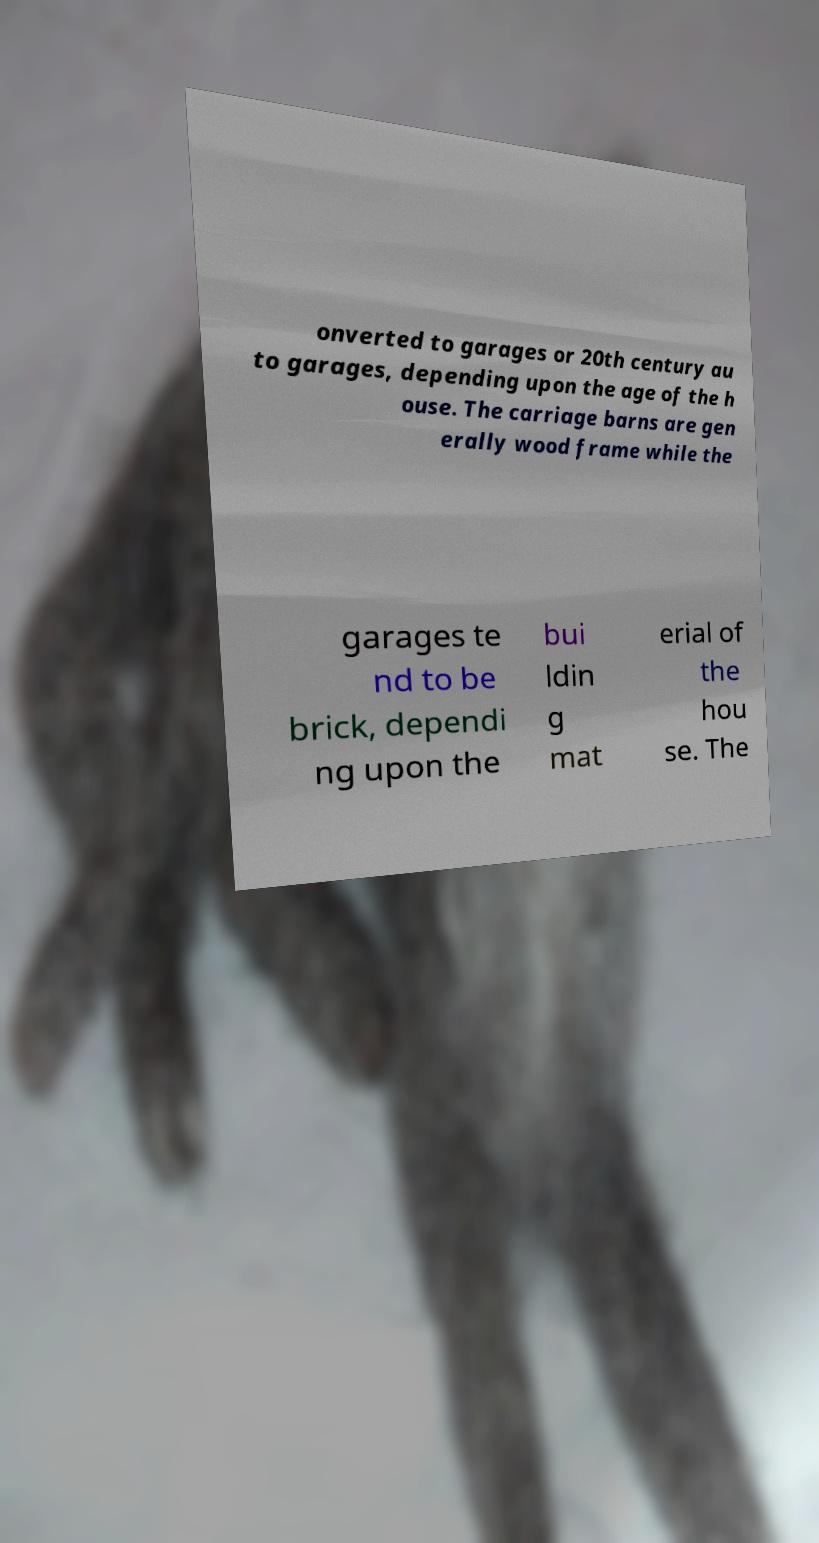Could you assist in decoding the text presented in this image and type it out clearly? onverted to garages or 20th century au to garages, depending upon the age of the h ouse. The carriage barns are gen erally wood frame while the garages te nd to be brick, dependi ng upon the bui ldin g mat erial of the hou se. The 